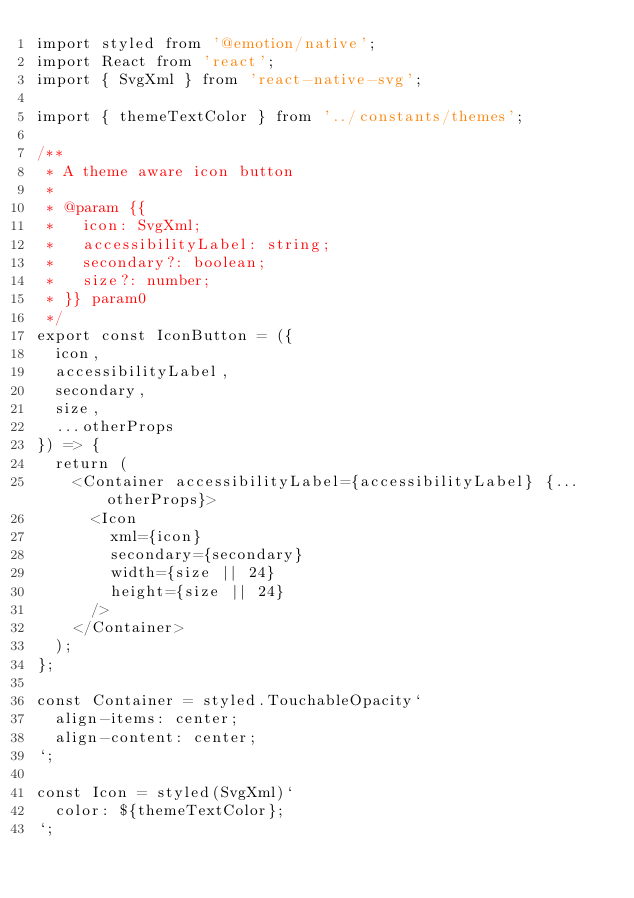Convert code to text. <code><loc_0><loc_0><loc_500><loc_500><_JavaScript_>import styled from '@emotion/native';
import React from 'react';
import { SvgXml } from 'react-native-svg';

import { themeTextColor } from '../constants/themes';

/**
 * A theme aware icon button
 *
 * @param {{
 *   icon: SvgXml;
 *   accessibilityLabel: string;
 *   secondary?: boolean;
 *   size?: number;
 * }} param0
 */
export const IconButton = ({
  icon,
  accessibilityLabel,
  secondary,
  size,
  ...otherProps
}) => {
  return (
    <Container accessibilityLabel={accessibilityLabel} {...otherProps}>
      <Icon
        xml={icon}
        secondary={secondary}
        width={size || 24}
        height={size || 24}
      />
    </Container>
  );
};

const Container = styled.TouchableOpacity`
  align-items: center;
  align-content: center;
`;

const Icon = styled(SvgXml)`
  color: ${themeTextColor};
`;
</code> 